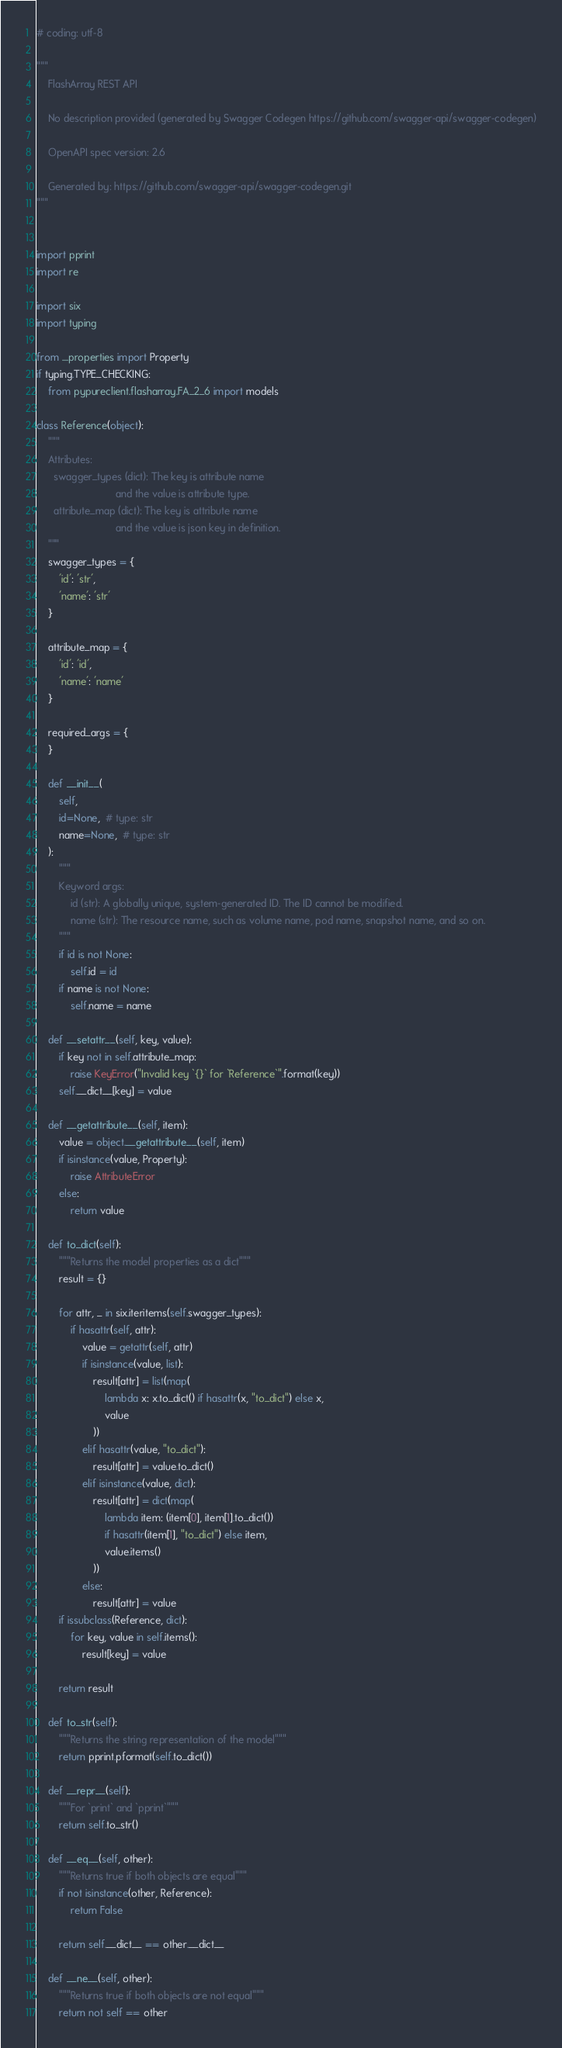Convert code to text. <code><loc_0><loc_0><loc_500><loc_500><_Python_># coding: utf-8

"""
    FlashArray REST API

    No description provided (generated by Swagger Codegen https://github.com/swagger-api/swagger-codegen)

    OpenAPI spec version: 2.6
    
    Generated by: https://github.com/swagger-api/swagger-codegen.git
"""


import pprint
import re

import six
import typing

from ....properties import Property
if typing.TYPE_CHECKING:
    from pypureclient.flasharray.FA_2_6 import models

class Reference(object):
    """
    Attributes:
      swagger_types (dict): The key is attribute name
                            and the value is attribute type.
      attribute_map (dict): The key is attribute name
                            and the value is json key in definition.
    """
    swagger_types = {
        'id': 'str',
        'name': 'str'
    }

    attribute_map = {
        'id': 'id',
        'name': 'name'
    }

    required_args = {
    }

    def __init__(
        self,
        id=None,  # type: str
        name=None,  # type: str
    ):
        """
        Keyword args:
            id (str): A globally unique, system-generated ID. The ID cannot be modified.
            name (str): The resource name, such as volume name, pod name, snapshot name, and so on.
        """
        if id is not None:
            self.id = id
        if name is not None:
            self.name = name

    def __setattr__(self, key, value):
        if key not in self.attribute_map:
            raise KeyError("Invalid key `{}` for `Reference`".format(key))
        self.__dict__[key] = value

    def __getattribute__(self, item):
        value = object.__getattribute__(self, item)
        if isinstance(value, Property):
            raise AttributeError
        else:
            return value

    def to_dict(self):
        """Returns the model properties as a dict"""
        result = {}

        for attr, _ in six.iteritems(self.swagger_types):
            if hasattr(self, attr):
                value = getattr(self, attr)
                if isinstance(value, list):
                    result[attr] = list(map(
                        lambda x: x.to_dict() if hasattr(x, "to_dict") else x,
                        value
                    ))
                elif hasattr(value, "to_dict"):
                    result[attr] = value.to_dict()
                elif isinstance(value, dict):
                    result[attr] = dict(map(
                        lambda item: (item[0], item[1].to_dict())
                        if hasattr(item[1], "to_dict") else item,
                        value.items()
                    ))
                else:
                    result[attr] = value
        if issubclass(Reference, dict):
            for key, value in self.items():
                result[key] = value

        return result

    def to_str(self):
        """Returns the string representation of the model"""
        return pprint.pformat(self.to_dict())

    def __repr__(self):
        """For `print` and `pprint`"""
        return self.to_str()

    def __eq__(self, other):
        """Returns true if both objects are equal"""
        if not isinstance(other, Reference):
            return False

        return self.__dict__ == other.__dict__

    def __ne__(self, other):
        """Returns true if both objects are not equal"""
        return not self == other
</code> 